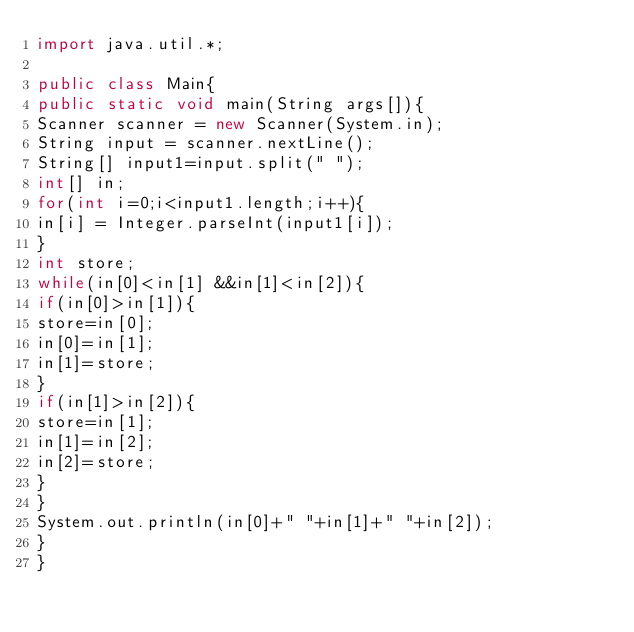<code> <loc_0><loc_0><loc_500><loc_500><_Java_>import java.util.*;

public class Main{
public static void main(String args[]){
Scanner scanner = new Scanner(System.in);
String input = scanner.nextLine();
String[] input1=input.split(" ");
int[] in;
for(int i=0;i<input1.length;i++){
in[i] = Integer.parseInt(input1[i]);
}
int store;
while(in[0]<in[1] &&in[1]<in[2]){
if(in[0]>in[1]){
store=in[0];
in[0]=in[1];
in[1]=store;
}
if(in[1]>in[2]){
store=in[1];
in[1]=in[2];
in[2]=store;
}
}
System.out.println(in[0]+" "+in[1]+" "+in[2]);
}
}</code> 